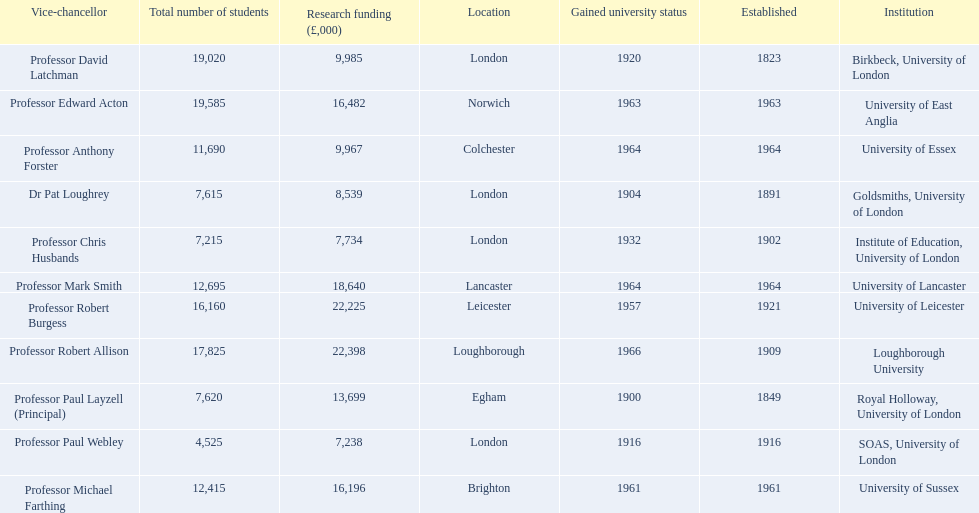Where is birbeck,university of london located? London. Which university was established in 1921? University of Leicester. Which institution gained university status recently? Loughborough University. 